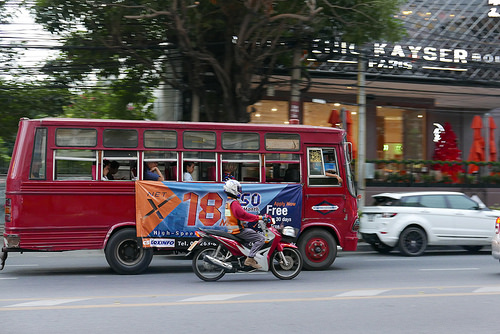<image>
Is the car to the left of the bus? Yes. From this viewpoint, the car is positioned to the left side relative to the bus. Is the bus behind the motorcycle? Yes. From this viewpoint, the bus is positioned behind the motorcycle, with the motorcycle partially or fully occluding the bus. Is there a bus in front of the motorcycle? No. The bus is not in front of the motorcycle. The spatial positioning shows a different relationship between these objects. 